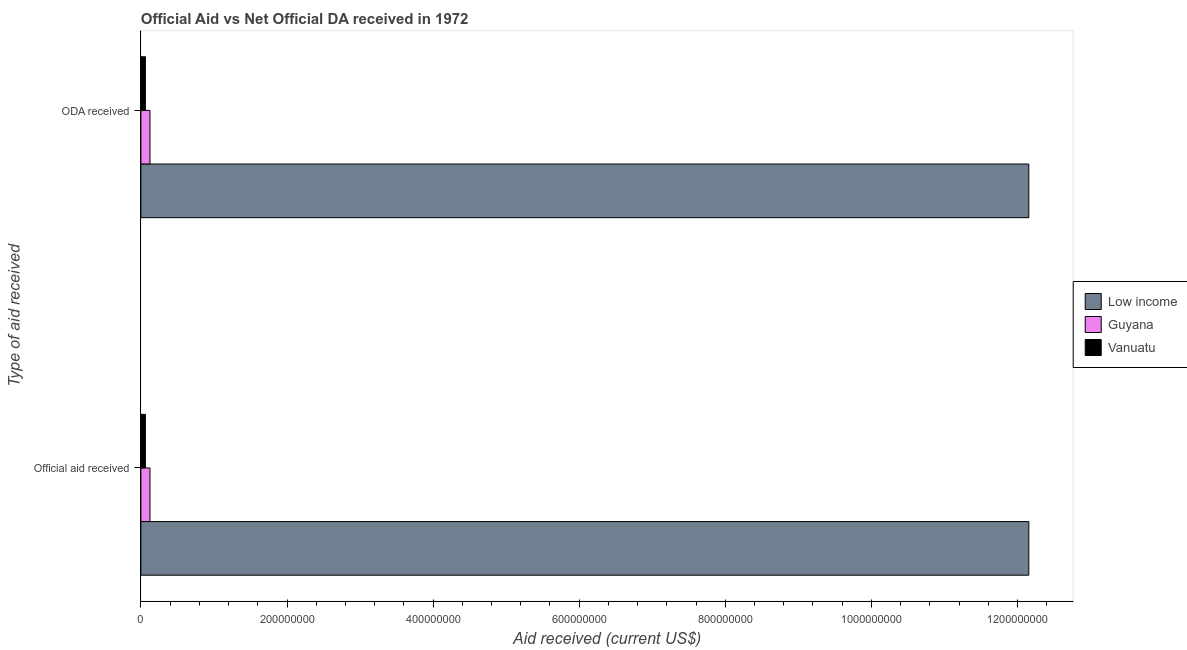How many groups of bars are there?
Ensure brevity in your answer.  2. Are the number of bars on each tick of the Y-axis equal?
Give a very brief answer. Yes. How many bars are there on the 1st tick from the bottom?
Your answer should be compact. 3. What is the label of the 1st group of bars from the top?
Provide a succinct answer. ODA received. What is the official aid received in Vanuatu?
Make the answer very short. 6.16e+06. Across all countries, what is the maximum official aid received?
Your answer should be very brief. 1.22e+09. Across all countries, what is the minimum oda received?
Keep it short and to the point. 6.16e+06. In which country was the official aid received maximum?
Give a very brief answer. Low income. In which country was the official aid received minimum?
Offer a very short reply. Vanuatu. What is the total official aid received in the graph?
Your answer should be very brief. 1.23e+09. What is the difference between the official aid received in Low income and that in Vanuatu?
Keep it short and to the point. 1.21e+09. What is the difference between the official aid received in Low income and the oda received in Guyana?
Your answer should be compact. 1.20e+09. What is the average official aid received per country?
Make the answer very short. 4.11e+08. In how many countries, is the oda received greater than 520000000 US$?
Provide a succinct answer. 1. What is the ratio of the oda received in Vanuatu to that in Guyana?
Your response must be concise. 0.49. Is the official aid received in Low income less than that in Guyana?
Keep it short and to the point. No. In how many countries, is the oda received greater than the average oda received taken over all countries?
Your answer should be very brief. 1. What does the 1st bar from the top in ODA received represents?
Give a very brief answer. Vanuatu. What does the 2nd bar from the bottom in ODA received represents?
Your answer should be compact. Guyana. How many countries are there in the graph?
Keep it short and to the point. 3. Does the graph contain any zero values?
Your answer should be compact. No. Where does the legend appear in the graph?
Provide a short and direct response. Center right. How many legend labels are there?
Keep it short and to the point. 3. What is the title of the graph?
Ensure brevity in your answer.  Official Aid vs Net Official DA received in 1972 . What is the label or title of the X-axis?
Your answer should be very brief. Aid received (current US$). What is the label or title of the Y-axis?
Your answer should be very brief. Type of aid received. What is the Aid received (current US$) in Low income in Official aid received?
Your answer should be very brief. 1.22e+09. What is the Aid received (current US$) of Guyana in Official aid received?
Give a very brief answer. 1.25e+07. What is the Aid received (current US$) in Vanuatu in Official aid received?
Keep it short and to the point. 6.16e+06. What is the Aid received (current US$) in Low income in ODA received?
Ensure brevity in your answer.  1.22e+09. What is the Aid received (current US$) of Guyana in ODA received?
Offer a terse response. 1.25e+07. What is the Aid received (current US$) of Vanuatu in ODA received?
Make the answer very short. 6.16e+06. Across all Type of aid received, what is the maximum Aid received (current US$) in Low income?
Your answer should be compact. 1.22e+09. Across all Type of aid received, what is the maximum Aid received (current US$) in Guyana?
Provide a succinct answer. 1.25e+07. Across all Type of aid received, what is the maximum Aid received (current US$) in Vanuatu?
Offer a terse response. 6.16e+06. Across all Type of aid received, what is the minimum Aid received (current US$) of Low income?
Your response must be concise. 1.22e+09. Across all Type of aid received, what is the minimum Aid received (current US$) of Guyana?
Make the answer very short. 1.25e+07. Across all Type of aid received, what is the minimum Aid received (current US$) in Vanuatu?
Provide a short and direct response. 6.16e+06. What is the total Aid received (current US$) of Low income in the graph?
Provide a succinct answer. 2.43e+09. What is the total Aid received (current US$) of Guyana in the graph?
Give a very brief answer. 2.49e+07. What is the total Aid received (current US$) in Vanuatu in the graph?
Make the answer very short. 1.23e+07. What is the difference between the Aid received (current US$) of Guyana in Official aid received and that in ODA received?
Your answer should be very brief. 0. What is the difference between the Aid received (current US$) of Vanuatu in Official aid received and that in ODA received?
Offer a terse response. 0. What is the difference between the Aid received (current US$) of Low income in Official aid received and the Aid received (current US$) of Guyana in ODA received?
Keep it short and to the point. 1.20e+09. What is the difference between the Aid received (current US$) of Low income in Official aid received and the Aid received (current US$) of Vanuatu in ODA received?
Offer a terse response. 1.21e+09. What is the difference between the Aid received (current US$) in Guyana in Official aid received and the Aid received (current US$) in Vanuatu in ODA received?
Ensure brevity in your answer.  6.30e+06. What is the average Aid received (current US$) in Low income per Type of aid received?
Keep it short and to the point. 1.22e+09. What is the average Aid received (current US$) of Guyana per Type of aid received?
Ensure brevity in your answer.  1.25e+07. What is the average Aid received (current US$) in Vanuatu per Type of aid received?
Ensure brevity in your answer.  6.16e+06. What is the difference between the Aid received (current US$) of Low income and Aid received (current US$) of Guyana in Official aid received?
Provide a succinct answer. 1.20e+09. What is the difference between the Aid received (current US$) in Low income and Aid received (current US$) in Vanuatu in Official aid received?
Make the answer very short. 1.21e+09. What is the difference between the Aid received (current US$) in Guyana and Aid received (current US$) in Vanuatu in Official aid received?
Provide a succinct answer. 6.30e+06. What is the difference between the Aid received (current US$) in Low income and Aid received (current US$) in Guyana in ODA received?
Make the answer very short. 1.20e+09. What is the difference between the Aid received (current US$) of Low income and Aid received (current US$) of Vanuatu in ODA received?
Make the answer very short. 1.21e+09. What is the difference between the Aid received (current US$) of Guyana and Aid received (current US$) of Vanuatu in ODA received?
Your answer should be very brief. 6.30e+06. What is the ratio of the Aid received (current US$) of Low income in Official aid received to that in ODA received?
Offer a very short reply. 1. What is the ratio of the Aid received (current US$) of Guyana in Official aid received to that in ODA received?
Keep it short and to the point. 1. What is the difference between the highest and the second highest Aid received (current US$) of Low income?
Your answer should be compact. 0. What is the difference between the highest and the second highest Aid received (current US$) of Guyana?
Provide a short and direct response. 0. What is the difference between the highest and the second highest Aid received (current US$) of Vanuatu?
Provide a short and direct response. 0. What is the difference between the highest and the lowest Aid received (current US$) of Low income?
Provide a succinct answer. 0. What is the difference between the highest and the lowest Aid received (current US$) of Vanuatu?
Give a very brief answer. 0. 